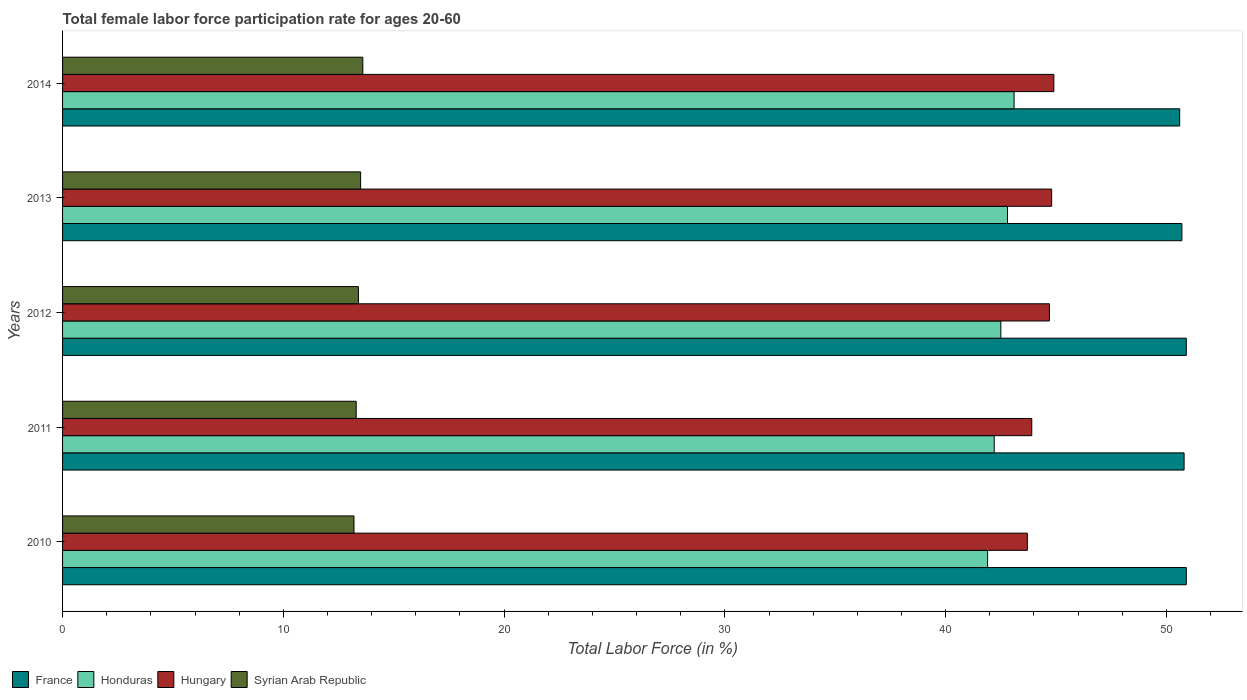How many groups of bars are there?
Make the answer very short. 5. Are the number of bars per tick equal to the number of legend labels?
Make the answer very short. Yes. Are the number of bars on each tick of the Y-axis equal?
Your answer should be very brief. Yes. How many bars are there on the 3rd tick from the bottom?
Offer a terse response. 4. What is the female labor force participation rate in Hungary in 2010?
Provide a succinct answer. 43.7. Across all years, what is the maximum female labor force participation rate in France?
Offer a very short reply. 50.9. Across all years, what is the minimum female labor force participation rate in Hungary?
Keep it short and to the point. 43.7. What is the total female labor force participation rate in Hungary in the graph?
Your answer should be compact. 222. What is the difference between the female labor force participation rate in Syrian Arab Republic in 2010 and the female labor force participation rate in Honduras in 2012?
Your answer should be very brief. -29.3. What is the ratio of the female labor force participation rate in Syrian Arab Republic in 2010 to that in 2012?
Give a very brief answer. 0.99. Is the difference between the female labor force participation rate in Honduras in 2011 and 2014 greater than the difference between the female labor force participation rate in Hungary in 2011 and 2014?
Your answer should be very brief. Yes. What is the difference between the highest and the lowest female labor force participation rate in France?
Your answer should be very brief. 0.3. What does the 2nd bar from the top in 2013 represents?
Your answer should be very brief. Hungary. What does the 1st bar from the bottom in 2012 represents?
Keep it short and to the point. France. Is it the case that in every year, the sum of the female labor force participation rate in Honduras and female labor force participation rate in France is greater than the female labor force participation rate in Syrian Arab Republic?
Offer a terse response. Yes. How many bars are there?
Provide a short and direct response. 20. How many years are there in the graph?
Make the answer very short. 5. What is the difference between two consecutive major ticks on the X-axis?
Your answer should be compact. 10. Does the graph contain grids?
Give a very brief answer. No. Where does the legend appear in the graph?
Your answer should be compact. Bottom left. How many legend labels are there?
Provide a short and direct response. 4. What is the title of the graph?
Make the answer very short. Total female labor force participation rate for ages 20-60. Does "Vanuatu" appear as one of the legend labels in the graph?
Make the answer very short. No. What is the label or title of the X-axis?
Your response must be concise. Total Labor Force (in %). What is the Total Labor Force (in %) of France in 2010?
Give a very brief answer. 50.9. What is the Total Labor Force (in %) in Honduras in 2010?
Your answer should be compact. 41.9. What is the Total Labor Force (in %) in Hungary in 2010?
Provide a short and direct response. 43.7. What is the Total Labor Force (in %) of Syrian Arab Republic in 2010?
Provide a short and direct response. 13.2. What is the Total Labor Force (in %) in France in 2011?
Offer a terse response. 50.8. What is the Total Labor Force (in %) of Honduras in 2011?
Provide a succinct answer. 42.2. What is the Total Labor Force (in %) of Hungary in 2011?
Offer a very short reply. 43.9. What is the Total Labor Force (in %) in Syrian Arab Republic in 2011?
Give a very brief answer. 13.3. What is the Total Labor Force (in %) of France in 2012?
Offer a terse response. 50.9. What is the Total Labor Force (in %) of Honduras in 2012?
Your answer should be very brief. 42.5. What is the Total Labor Force (in %) in Hungary in 2012?
Offer a very short reply. 44.7. What is the Total Labor Force (in %) in Syrian Arab Republic in 2012?
Keep it short and to the point. 13.4. What is the Total Labor Force (in %) of France in 2013?
Offer a very short reply. 50.7. What is the Total Labor Force (in %) in Honduras in 2013?
Provide a short and direct response. 42.8. What is the Total Labor Force (in %) of Hungary in 2013?
Give a very brief answer. 44.8. What is the Total Labor Force (in %) of Syrian Arab Republic in 2013?
Offer a very short reply. 13.5. What is the Total Labor Force (in %) of France in 2014?
Ensure brevity in your answer.  50.6. What is the Total Labor Force (in %) of Honduras in 2014?
Your answer should be very brief. 43.1. What is the Total Labor Force (in %) of Hungary in 2014?
Your answer should be very brief. 44.9. What is the Total Labor Force (in %) of Syrian Arab Republic in 2014?
Your answer should be very brief. 13.6. Across all years, what is the maximum Total Labor Force (in %) in France?
Ensure brevity in your answer.  50.9. Across all years, what is the maximum Total Labor Force (in %) of Honduras?
Offer a very short reply. 43.1. Across all years, what is the maximum Total Labor Force (in %) of Hungary?
Provide a succinct answer. 44.9. Across all years, what is the maximum Total Labor Force (in %) of Syrian Arab Republic?
Give a very brief answer. 13.6. Across all years, what is the minimum Total Labor Force (in %) in France?
Give a very brief answer. 50.6. Across all years, what is the minimum Total Labor Force (in %) in Honduras?
Your response must be concise. 41.9. Across all years, what is the minimum Total Labor Force (in %) in Hungary?
Provide a succinct answer. 43.7. Across all years, what is the minimum Total Labor Force (in %) of Syrian Arab Republic?
Your answer should be compact. 13.2. What is the total Total Labor Force (in %) in France in the graph?
Your answer should be compact. 253.9. What is the total Total Labor Force (in %) in Honduras in the graph?
Ensure brevity in your answer.  212.5. What is the total Total Labor Force (in %) of Hungary in the graph?
Ensure brevity in your answer.  222. What is the difference between the Total Labor Force (in %) in Syrian Arab Republic in 2010 and that in 2011?
Keep it short and to the point. -0.1. What is the difference between the Total Labor Force (in %) of Syrian Arab Republic in 2010 and that in 2012?
Offer a very short reply. -0.2. What is the difference between the Total Labor Force (in %) in Syrian Arab Republic in 2010 and that in 2013?
Give a very brief answer. -0.3. What is the difference between the Total Labor Force (in %) of Honduras in 2011 and that in 2012?
Your answer should be compact. -0.3. What is the difference between the Total Labor Force (in %) of Hungary in 2011 and that in 2012?
Keep it short and to the point. -0.8. What is the difference between the Total Labor Force (in %) of Syrian Arab Republic in 2011 and that in 2012?
Provide a succinct answer. -0.1. What is the difference between the Total Labor Force (in %) of France in 2011 and that in 2014?
Give a very brief answer. 0.2. What is the difference between the Total Labor Force (in %) of Honduras in 2011 and that in 2014?
Offer a terse response. -0.9. What is the difference between the Total Labor Force (in %) in Hungary in 2011 and that in 2014?
Your answer should be very brief. -1. What is the difference between the Total Labor Force (in %) of Syrian Arab Republic in 2011 and that in 2014?
Your answer should be compact. -0.3. What is the difference between the Total Labor Force (in %) in Honduras in 2012 and that in 2013?
Your answer should be very brief. -0.3. What is the difference between the Total Labor Force (in %) of Syrian Arab Republic in 2012 and that in 2013?
Make the answer very short. -0.1. What is the difference between the Total Labor Force (in %) of France in 2012 and that in 2014?
Give a very brief answer. 0.3. What is the difference between the Total Labor Force (in %) of Hungary in 2012 and that in 2014?
Your response must be concise. -0.2. What is the difference between the Total Labor Force (in %) in Syrian Arab Republic in 2012 and that in 2014?
Your answer should be very brief. -0.2. What is the difference between the Total Labor Force (in %) of Hungary in 2013 and that in 2014?
Offer a terse response. -0.1. What is the difference between the Total Labor Force (in %) of France in 2010 and the Total Labor Force (in %) of Honduras in 2011?
Your answer should be compact. 8.7. What is the difference between the Total Labor Force (in %) of France in 2010 and the Total Labor Force (in %) of Syrian Arab Republic in 2011?
Offer a terse response. 37.6. What is the difference between the Total Labor Force (in %) in Honduras in 2010 and the Total Labor Force (in %) in Hungary in 2011?
Give a very brief answer. -2. What is the difference between the Total Labor Force (in %) of Honduras in 2010 and the Total Labor Force (in %) of Syrian Arab Republic in 2011?
Your answer should be compact. 28.6. What is the difference between the Total Labor Force (in %) of Hungary in 2010 and the Total Labor Force (in %) of Syrian Arab Republic in 2011?
Your response must be concise. 30.4. What is the difference between the Total Labor Force (in %) in France in 2010 and the Total Labor Force (in %) in Syrian Arab Republic in 2012?
Give a very brief answer. 37.5. What is the difference between the Total Labor Force (in %) of Honduras in 2010 and the Total Labor Force (in %) of Hungary in 2012?
Ensure brevity in your answer.  -2.8. What is the difference between the Total Labor Force (in %) in Honduras in 2010 and the Total Labor Force (in %) in Syrian Arab Republic in 2012?
Your response must be concise. 28.5. What is the difference between the Total Labor Force (in %) of Hungary in 2010 and the Total Labor Force (in %) of Syrian Arab Republic in 2012?
Your response must be concise. 30.3. What is the difference between the Total Labor Force (in %) of France in 2010 and the Total Labor Force (in %) of Honduras in 2013?
Offer a terse response. 8.1. What is the difference between the Total Labor Force (in %) of France in 2010 and the Total Labor Force (in %) of Syrian Arab Republic in 2013?
Provide a short and direct response. 37.4. What is the difference between the Total Labor Force (in %) in Honduras in 2010 and the Total Labor Force (in %) in Hungary in 2013?
Your answer should be very brief. -2.9. What is the difference between the Total Labor Force (in %) of Honduras in 2010 and the Total Labor Force (in %) of Syrian Arab Republic in 2013?
Offer a very short reply. 28.4. What is the difference between the Total Labor Force (in %) in Hungary in 2010 and the Total Labor Force (in %) in Syrian Arab Republic in 2013?
Provide a short and direct response. 30.2. What is the difference between the Total Labor Force (in %) in France in 2010 and the Total Labor Force (in %) in Honduras in 2014?
Your response must be concise. 7.8. What is the difference between the Total Labor Force (in %) in France in 2010 and the Total Labor Force (in %) in Hungary in 2014?
Offer a terse response. 6. What is the difference between the Total Labor Force (in %) of France in 2010 and the Total Labor Force (in %) of Syrian Arab Republic in 2014?
Ensure brevity in your answer.  37.3. What is the difference between the Total Labor Force (in %) in Honduras in 2010 and the Total Labor Force (in %) in Syrian Arab Republic in 2014?
Provide a succinct answer. 28.3. What is the difference between the Total Labor Force (in %) in Hungary in 2010 and the Total Labor Force (in %) in Syrian Arab Republic in 2014?
Your answer should be compact. 30.1. What is the difference between the Total Labor Force (in %) in France in 2011 and the Total Labor Force (in %) in Honduras in 2012?
Your response must be concise. 8.3. What is the difference between the Total Labor Force (in %) of France in 2011 and the Total Labor Force (in %) of Syrian Arab Republic in 2012?
Provide a succinct answer. 37.4. What is the difference between the Total Labor Force (in %) in Honduras in 2011 and the Total Labor Force (in %) in Syrian Arab Republic in 2012?
Your answer should be compact. 28.8. What is the difference between the Total Labor Force (in %) of Hungary in 2011 and the Total Labor Force (in %) of Syrian Arab Republic in 2012?
Your response must be concise. 30.5. What is the difference between the Total Labor Force (in %) of France in 2011 and the Total Labor Force (in %) of Honduras in 2013?
Your answer should be compact. 8. What is the difference between the Total Labor Force (in %) of France in 2011 and the Total Labor Force (in %) of Syrian Arab Republic in 2013?
Make the answer very short. 37.3. What is the difference between the Total Labor Force (in %) in Honduras in 2011 and the Total Labor Force (in %) in Hungary in 2013?
Give a very brief answer. -2.6. What is the difference between the Total Labor Force (in %) of Honduras in 2011 and the Total Labor Force (in %) of Syrian Arab Republic in 2013?
Keep it short and to the point. 28.7. What is the difference between the Total Labor Force (in %) in Hungary in 2011 and the Total Labor Force (in %) in Syrian Arab Republic in 2013?
Make the answer very short. 30.4. What is the difference between the Total Labor Force (in %) of France in 2011 and the Total Labor Force (in %) of Syrian Arab Republic in 2014?
Make the answer very short. 37.2. What is the difference between the Total Labor Force (in %) in Honduras in 2011 and the Total Labor Force (in %) in Syrian Arab Republic in 2014?
Keep it short and to the point. 28.6. What is the difference between the Total Labor Force (in %) in Hungary in 2011 and the Total Labor Force (in %) in Syrian Arab Republic in 2014?
Provide a short and direct response. 30.3. What is the difference between the Total Labor Force (in %) in France in 2012 and the Total Labor Force (in %) in Honduras in 2013?
Provide a succinct answer. 8.1. What is the difference between the Total Labor Force (in %) of France in 2012 and the Total Labor Force (in %) of Hungary in 2013?
Keep it short and to the point. 6.1. What is the difference between the Total Labor Force (in %) in France in 2012 and the Total Labor Force (in %) in Syrian Arab Republic in 2013?
Keep it short and to the point. 37.4. What is the difference between the Total Labor Force (in %) in Honduras in 2012 and the Total Labor Force (in %) in Hungary in 2013?
Offer a terse response. -2.3. What is the difference between the Total Labor Force (in %) in Honduras in 2012 and the Total Labor Force (in %) in Syrian Arab Republic in 2013?
Your answer should be very brief. 29. What is the difference between the Total Labor Force (in %) in Hungary in 2012 and the Total Labor Force (in %) in Syrian Arab Republic in 2013?
Make the answer very short. 31.2. What is the difference between the Total Labor Force (in %) in France in 2012 and the Total Labor Force (in %) in Honduras in 2014?
Offer a very short reply. 7.8. What is the difference between the Total Labor Force (in %) of France in 2012 and the Total Labor Force (in %) of Hungary in 2014?
Offer a terse response. 6. What is the difference between the Total Labor Force (in %) in France in 2012 and the Total Labor Force (in %) in Syrian Arab Republic in 2014?
Your answer should be very brief. 37.3. What is the difference between the Total Labor Force (in %) of Honduras in 2012 and the Total Labor Force (in %) of Syrian Arab Republic in 2014?
Your answer should be very brief. 28.9. What is the difference between the Total Labor Force (in %) in Hungary in 2012 and the Total Labor Force (in %) in Syrian Arab Republic in 2014?
Provide a short and direct response. 31.1. What is the difference between the Total Labor Force (in %) in France in 2013 and the Total Labor Force (in %) in Honduras in 2014?
Keep it short and to the point. 7.6. What is the difference between the Total Labor Force (in %) of France in 2013 and the Total Labor Force (in %) of Hungary in 2014?
Give a very brief answer. 5.8. What is the difference between the Total Labor Force (in %) in France in 2013 and the Total Labor Force (in %) in Syrian Arab Republic in 2014?
Offer a very short reply. 37.1. What is the difference between the Total Labor Force (in %) of Honduras in 2013 and the Total Labor Force (in %) of Hungary in 2014?
Your answer should be compact. -2.1. What is the difference between the Total Labor Force (in %) of Honduras in 2013 and the Total Labor Force (in %) of Syrian Arab Republic in 2014?
Ensure brevity in your answer.  29.2. What is the difference between the Total Labor Force (in %) of Hungary in 2013 and the Total Labor Force (in %) of Syrian Arab Republic in 2014?
Keep it short and to the point. 31.2. What is the average Total Labor Force (in %) in France per year?
Your answer should be compact. 50.78. What is the average Total Labor Force (in %) in Honduras per year?
Your response must be concise. 42.5. What is the average Total Labor Force (in %) of Hungary per year?
Offer a terse response. 44.4. In the year 2010, what is the difference between the Total Labor Force (in %) in France and Total Labor Force (in %) in Honduras?
Provide a succinct answer. 9. In the year 2010, what is the difference between the Total Labor Force (in %) of France and Total Labor Force (in %) of Syrian Arab Republic?
Give a very brief answer. 37.7. In the year 2010, what is the difference between the Total Labor Force (in %) in Honduras and Total Labor Force (in %) in Hungary?
Your answer should be very brief. -1.8. In the year 2010, what is the difference between the Total Labor Force (in %) in Honduras and Total Labor Force (in %) in Syrian Arab Republic?
Ensure brevity in your answer.  28.7. In the year 2010, what is the difference between the Total Labor Force (in %) in Hungary and Total Labor Force (in %) in Syrian Arab Republic?
Your answer should be very brief. 30.5. In the year 2011, what is the difference between the Total Labor Force (in %) of France and Total Labor Force (in %) of Honduras?
Your answer should be very brief. 8.6. In the year 2011, what is the difference between the Total Labor Force (in %) in France and Total Labor Force (in %) in Syrian Arab Republic?
Offer a very short reply. 37.5. In the year 2011, what is the difference between the Total Labor Force (in %) of Honduras and Total Labor Force (in %) of Syrian Arab Republic?
Your answer should be compact. 28.9. In the year 2011, what is the difference between the Total Labor Force (in %) of Hungary and Total Labor Force (in %) of Syrian Arab Republic?
Your answer should be compact. 30.6. In the year 2012, what is the difference between the Total Labor Force (in %) in France and Total Labor Force (in %) in Syrian Arab Republic?
Your answer should be very brief. 37.5. In the year 2012, what is the difference between the Total Labor Force (in %) of Honduras and Total Labor Force (in %) of Syrian Arab Republic?
Provide a short and direct response. 29.1. In the year 2012, what is the difference between the Total Labor Force (in %) in Hungary and Total Labor Force (in %) in Syrian Arab Republic?
Provide a short and direct response. 31.3. In the year 2013, what is the difference between the Total Labor Force (in %) in France and Total Labor Force (in %) in Honduras?
Ensure brevity in your answer.  7.9. In the year 2013, what is the difference between the Total Labor Force (in %) of France and Total Labor Force (in %) of Hungary?
Give a very brief answer. 5.9. In the year 2013, what is the difference between the Total Labor Force (in %) of France and Total Labor Force (in %) of Syrian Arab Republic?
Keep it short and to the point. 37.2. In the year 2013, what is the difference between the Total Labor Force (in %) of Honduras and Total Labor Force (in %) of Syrian Arab Republic?
Keep it short and to the point. 29.3. In the year 2013, what is the difference between the Total Labor Force (in %) of Hungary and Total Labor Force (in %) of Syrian Arab Republic?
Ensure brevity in your answer.  31.3. In the year 2014, what is the difference between the Total Labor Force (in %) of Honduras and Total Labor Force (in %) of Syrian Arab Republic?
Offer a terse response. 29.5. In the year 2014, what is the difference between the Total Labor Force (in %) of Hungary and Total Labor Force (in %) of Syrian Arab Republic?
Your response must be concise. 31.3. What is the ratio of the Total Labor Force (in %) of France in 2010 to that in 2011?
Offer a terse response. 1. What is the ratio of the Total Labor Force (in %) in Honduras in 2010 to that in 2011?
Make the answer very short. 0.99. What is the ratio of the Total Labor Force (in %) of Syrian Arab Republic in 2010 to that in 2011?
Your answer should be compact. 0.99. What is the ratio of the Total Labor Force (in %) of France in 2010 to that in 2012?
Provide a succinct answer. 1. What is the ratio of the Total Labor Force (in %) in Honduras in 2010 to that in 2012?
Keep it short and to the point. 0.99. What is the ratio of the Total Labor Force (in %) of Hungary in 2010 to that in 2012?
Make the answer very short. 0.98. What is the ratio of the Total Labor Force (in %) of Syrian Arab Republic in 2010 to that in 2012?
Make the answer very short. 0.99. What is the ratio of the Total Labor Force (in %) in Honduras in 2010 to that in 2013?
Make the answer very short. 0.98. What is the ratio of the Total Labor Force (in %) in Hungary in 2010 to that in 2013?
Offer a terse response. 0.98. What is the ratio of the Total Labor Force (in %) in Syrian Arab Republic in 2010 to that in 2013?
Provide a short and direct response. 0.98. What is the ratio of the Total Labor Force (in %) of France in 2010 to that in 2014?
Make the answer very short. 1.01. What is the ratio of the Total Labor Force (in %) of Honduras in 2010 to that in 2014?
Provide a succinct answer. 0.97. What is the ratio of the Total Labor Force (in %) of Hungary in 2010 to that in 2014?
Ensure brevity in your answer.  0.97. What is the ratio of the Total Labor Force (in %) in Syrian Arab Republic in 2010 to that in 2014?
Give a very brief answer. 0.97. What is the ratio of the Total Labor Force (in %) of Honduras in 2011 to that in 2012?
Make the answer very short. 0.99. What is the ratio of the Total Labor Force (in %) of Hungary in 2011 to that in 2012?
Your answer should be compact. 0.98. What is the ratio of the Total Labor Force (in %) of Honduras in 2011 to that in 2013?
Keep it short and to the point. 0.99. What is the ratio of the Total Labor Force (in %) of Hungary in 2011 to that in 2013?
Provide a short and direct response. 0.98. What is the ratio of the Total Labor Force (in %) of Syrian Arab Republic in 2011 to that in 2013?
Offer a terse response. 0.99. What is the ratio of the Total Labor Force (in %) of Honduras in 2011 to that in 2014?
Your answer should be compact. 0.98. What is the ratio of the Total Labor Force (in %) of Hungary in 2011 to that in 2014?
Give a very brief answer. 0.98. What is the ratio of the Total Labor Force (in %) in Syrian Arab Republic in 2011 to that in 2014?
Offer a terse response. 0.98. What is the ratio of the Total Labor Force (in %) in France in 2012 to that in 2013?
Keep it short and to the point. 1. What is the ratio of the Total Labor Force (in %) in France in 2012 to that in 2014?
Offer a terse response. 1.01. What is the ratio of the Total Labor Force (in %) of Honduras in 2012 to that in 2014?
Offer a very short reply. 0.99. What is the ratio of the Total Labor Force (in %) of France in 2013 to that in 2014?
Provide a short and direct response. 1. What is the ratio of the Total Labor Force (in %) in Hungary in 2013 to that in 2014?
Offer a terse response. 1. What is the ratio of the Total Labor Force (in %) of Syrian Arab Republic in 2013 to that in 2014?
Make the answer very short. 0.99. What is the difference between the highest and the second highest Total Labor Force (in %) in Honduras?
Offer a very short reply. 0.3. What is the difference between the highest and the second highest Total Labor Force (in %) of Hungary?
Your answer should be very brief. 0.1. What is the difference between the highest and the lowest Total Labor Force (in %) in Syrian Arab Republic?
Offer a terse response. 0.4. 